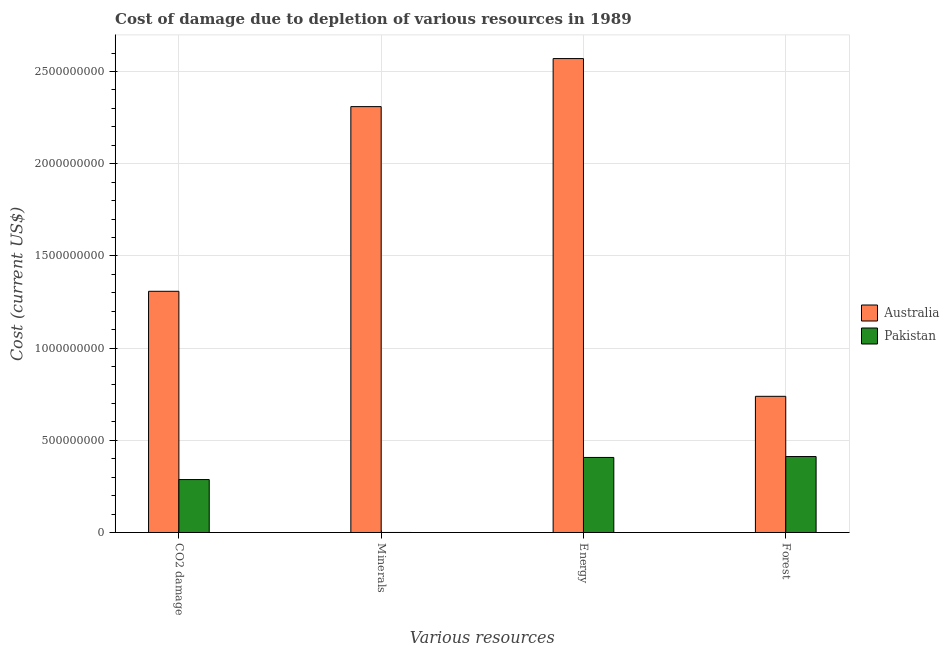How many bars are there on the 2nd tick from the left?
Offer a terse response. 2. How many bars are there on the 3rd tick from the right?
Provide a short and direct response. 2. What is the label of the 4th group of bars from the left?
Offer a terse response. Forest. What is the cost of damage due to depletion of coal in Australia?
Provide a succinct answer. 1.31e+09. Across all countries, what is the maximum cost of damage due to depletion of energy?
Your response must be concise. 2.57e+09. Across all countries, what is the minimum cost of damage due to depletion of minerals?
Your answer should be compact. 2.33e+04. What is the total cost of damage due to depletion of energy in the graph?
Make the answer very short. 2.98e+09. What is the difference between the cost of damage due to depletion of energy in Australia and that in Pakistan?
Provide a succinct answer. 2.16e+09. What is the difference between the cost of damage due to depletion of energy in Pakistan and the cost of damage due to depletion of coal in Australia?
Keep it short and to the point. -9.01e+08. What is the average cost of damage due to depletion of coal per country?
Give a very brief answer. 7.98e+08. What is the difference between the cost of damage due to depletion of energy and cost of damage due to depletion of coal in Pakistan?
Offer a terse response. 1.20e+08. In how many countries, is the cost of damage due to depletion of energy greater than 1100000000 US$?
Offer a very short reply. 1. What is the ratio of the cost of damage due to depletion of forests in Pakistan to that in Australia?
Ensure brevity in your answer.  0.56. Is the cost of damage due to depletion of coal in Pakistan less than that in Australia?
Offer a terse response. Yes. What is the difference between the highest and the second highest cost of damage due to depletion of coal?
Ensure brevity in your answer.  1.02e+09. What is the difference between the highest and the lowest cost of damage due to depletion of minerals?
Offer a terse response. 2.31e+09. In how many countries, is the cost of damage due to depletion of energy greater than the average cost of damage due to depletion of energy taken over all countries?
Offer a very short reply. 1. What does the 2nd bar from the right in Minerals represents?
Keep it short and to the point. Australia. Does the graph contain grids?
Offer a very short reply. Yes. How many legend labels are there?
Provide a short and direct response. 2. What is the title of the graph?
Your response must be concise. Cost of damage due to depletion of various resources in 1989 . Does "Bosnia and Herzegovina" appear as one of the legend labels in the graph?
Offer a terse response. No. What is the label or title of the X-axis?
Keep it short and to the point. Various resources. What is the label or title of the Y-axis?
Offer a terse response. Cost (current US$). What is the Cost (current US$) in Australia in CO2 damage?
Keep it short and to the point. 1.31e+09. What is the Cost (current US$) in Pakistan in CO2 damage?
Your answer should be compact. 2.87e+08. What is the Cost (current US$) of Australia in Minerals?
Your response must be concise. 2.31e+09. What is the Cost (current US$) of Pakistan in Minerals?
Ensure brevity in your answer.  2.33e+04. What is the Cost (current US$) in Australia in Energy?
Keep it short and to the point. 2.57e+09. What is the Cost (current US$) in Pakistan in Energy?
Provide a short and direct response. 4.07e+08. What is the Cost (current US$) in Australia in Forest?
Keep it short and to the point. 7.39e+08. What is the Cost (current US$) of Pakistan in Forest?
Keep it short and to the point. 4.12e+08. Across all Various resources, what is the maximum Cost (current US$) in Australia?
Keep it short and to the point. 2.57e+09. Across all Various resources, what is the maximum Cost (current US$) of Pakistan?
Keep it short and to the point. 4.12e+08. Across all Various resources, what is the minimum Cost (current US$) of Australia?
Your answer should be compact. 7.39e+08. Across all Various resources, what is the minimum Cost (current US$) of Pakistan?
Offer a terse response. 2.33e+04. What is the total Cost (current US$) in Australia in the graph?
Provide a succinct answer. 6.93e+09. What is the total Cost (current US$) of Pakistan in the graph?
Offer a very short reply. 1.11e+09. What is the difference between the Cost (current US$) of Australia in CO2 damage and that in Minerals?
Offer a terse response. -1.00e+09. What is the difference between the Cost (current US$) of Pakistan in CO2 damage and that in Minerals?
Give a very brief answer. 2.87e+08. What is the difference between the Cost (current US$) of Australia in CO2 damage and that in Energy?
Offer a terse response. -1.26e+09. What is the difference between the Cost (current US$) in Pakistan in CO2 damage and that in Energy?
Offer a very short reply. -1.20e+08. What is the difference between the Cost (current US$) of Australia in CO2 damage and that in Forest?
Provide a short and direct response. 5.70e+08. What is the difference between the Cost (current US$) in Pakistan in CO2 damage and that in Forest?
Provide a succinct answer. -1.25e+08. What is the difference between the Cost (current US$) of Australia in Minerals and that in Energy?
Offer a terse response. -2.61e+08. What is the difference between the Cost (current US$) of Pakistan in Minerals and that in Energy?
Offer a very short reply. -4.07e+08. What is the difference between the Cost (current US$) in Australia in Minerals and that in Forest?
Provide a succinct answer. 1.57e+09. What is the difference between the Cost (current US$) in Pakistan in Minerals and that in Forest?
Your answer should be very brief. -4.12e+08. What is the difference between the Cost (current US$) of Australia in Energy and that in Forest?
Your response must be concise. 1.83e+09. What is the difference between the Cost (current US$) of Pakistan in Energy and that in Forest?
Give a very brief answer. -4.92e+06. What is the difference between the Cost (current US$) of Australia in CO2 damage and the Cost (current US$) of Pakistan in Minerals?
Give a very brief answer. 1.31e+09. What is the difference between the Cost (current US$) of Australia in CO2 damage and the Cost (current US$) of Pakistan in Energy?
Provide a succinct answer. 9.01e+08. What is the difference between the Cost (current US$) of Australia in CO2 damage and the Cost (current US$) of Pakistan in Forest?
Offer a very short reply. 8.96e+08. What is the difference between the Cost (current US$) of Australia in Minerals and the Cost (current US$) of Pakistan in Energy?
Offer a terse response. 1.90e+09. What is the difference between the Cost (current US$) of Australia in Minerals and the Cost (current US$) of Pakistan in Forest?
Your response must be concise. 1.90e+09. What is the difference between the Cost (current US$) in Australia in Energy and the Cost (current US$) in Pakistan in Forest?
Your response must be concise. 2.16e+09. What is the average Cost (current US$) of Australia per Various resources?
Keep it short and to the point. 1.73e+09. What is the average Cost (current US$) of Pakistan per Various resources?
Keep it short and to the point. 2.77e+08. What is the difference between the Cost (current US$) of Australia and Cost (current US$) of Pakistan in CO2 damage?
Offer a terse response. 1.02e+09. What is the difference between the Cost (current US$) in Australia and Cost (current US$) in Pakistan in Minerals?
Offer a very short reply. 2.31e+09. What is the difference between the Cost (current US$) in Australia and Cost (current US$) in Pakistan in Energy?
Give a very brief answer. 2.16e+09. What is the difference between the Cost (current US$) of Australia and Cost (current US$) of Pakistan in Forest?
Ensure brevity in your answer.  3.27e+08. What is the ratio of the Cost (current US$) of Australia in CO2 damage to that in Minerals?
Provide a succinct answer. 0.57. What is the ratio of the Cost (current US$) in Pakistan in CO2 damage to that in Minerals?
Your response must be concise. 1.23e+04. What is the ratio of the Cost (current US$) in Australia in CO2 damage to that in Energy?
Make the answer very short. 0.51. What is the ratio of the Cost (current US$) in Pakistan in CO2 damage to that in Energy?
Make the answer very short. 0.71. What is the ratio of the Cost (current US$) of Australia in CO2 damage to that in Forest?
Offer a very short reply. 1.77. What is the ratio of the Cost (current US$) in Pakistan in CO2 damage to that in Forest?
Make the answer very short. 0.7. What is the ratio of the Cost (current US$) in Australia in Minerals to that in Energy?
Offer a terse response. 0.9. What is the ratio of the Cost (current US$) in Pakistan in Minerals to that in Energy?
Ensure brevity in your answer.  0. What is the ratio of the Cost (current US$) of Australia in Minerals to that in Forest?
Provide a succinct answer. 3.13. What is the ratio of the Cost (current US$) in Australia in Energy to that in Forest?
Provide a succinct answer. 3.48. What is the ratio of the Cost (current US$) of Pakistan in Energy to that in Forest?
Ensure brevity in your answer.  0.99. What is the difference between the highest and the second highest Cost (current US$) of Australia?
Make the answer very short. 2.61e+08. What is the difference between the highest and the second highest Cost (current US$) of Pakistan?
Ensure brevity in your answer.  4.92e+06. What is the difference between the highest and the lowest Cost (current US$) in Australia?
Give a very brief answer. 1.83e+09. What is the difference between the highest and the lowest Cost (current US$) in Pakistan?
Offer a very short reply. 4.12e+08. 